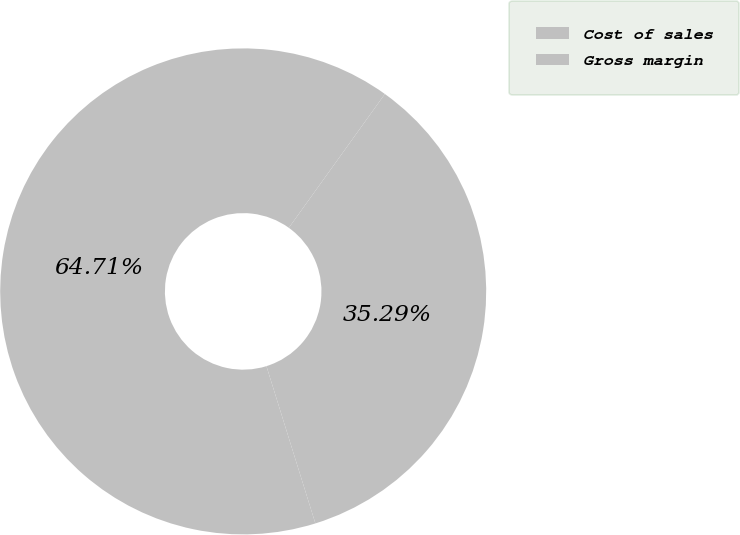<chart> <loc_0><loc_0><loc_500><loc_500><pie_chart><fcel>Cost of sales<fcel>Gross margin<nl><fcel>35.29%<fcel>64.71%<nl></chart> 